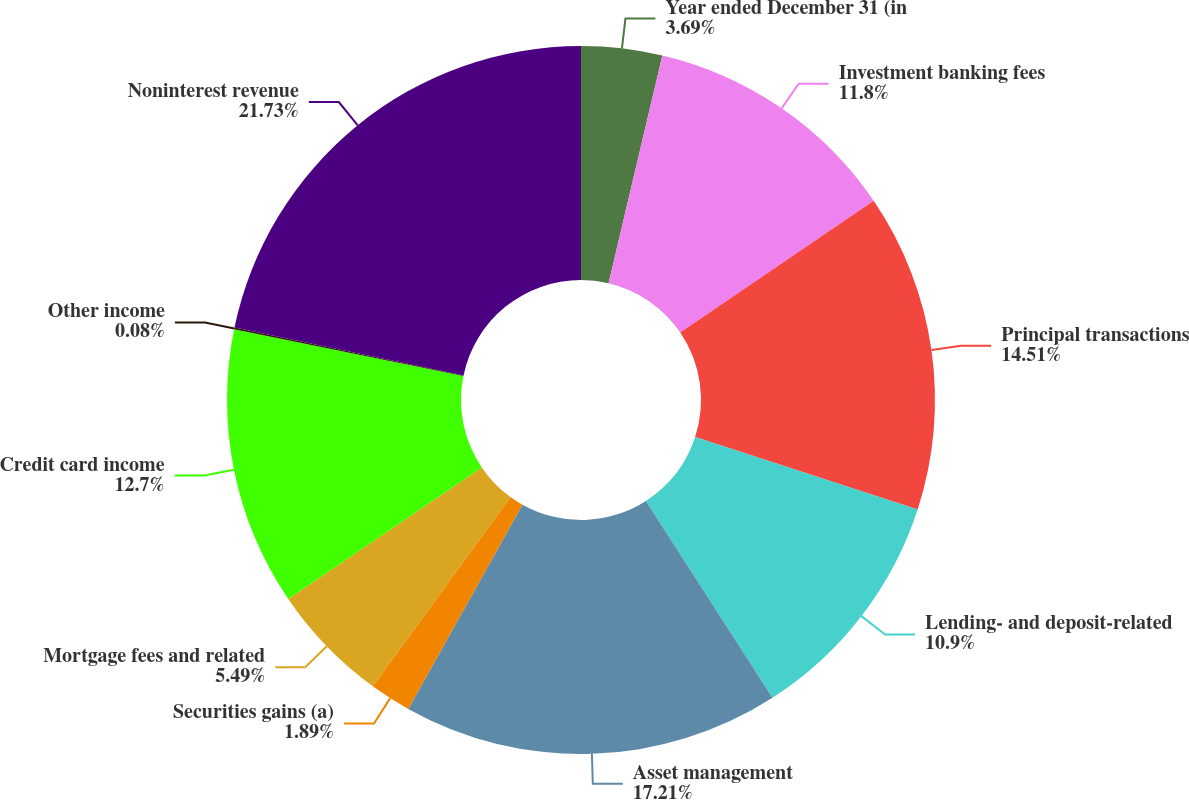<chart> <loc_0><loc_0><loc_500><loc_500><pie_chart><fcel>Year ended December 31 (in<fcel>Investment banking fees<fcel>Principal transactions<fcel>Lending- and deposit-related<fcel>Asset management<fcel>Securities gains (a)<fcel>Mortgage fees and related<fcel>Credit card income<fcel>Other income<fcel>Noninterest revenue<nl><fcel>3.69%<fcel>11.8%<fcel>14.51%<fcel>10.9%<fcel>17.21%<fcel>1.89%<fcel>5.49%<fcel>12.7%<fcel>0.08%<fcel>21.72%<nl></chart> 